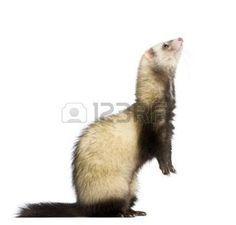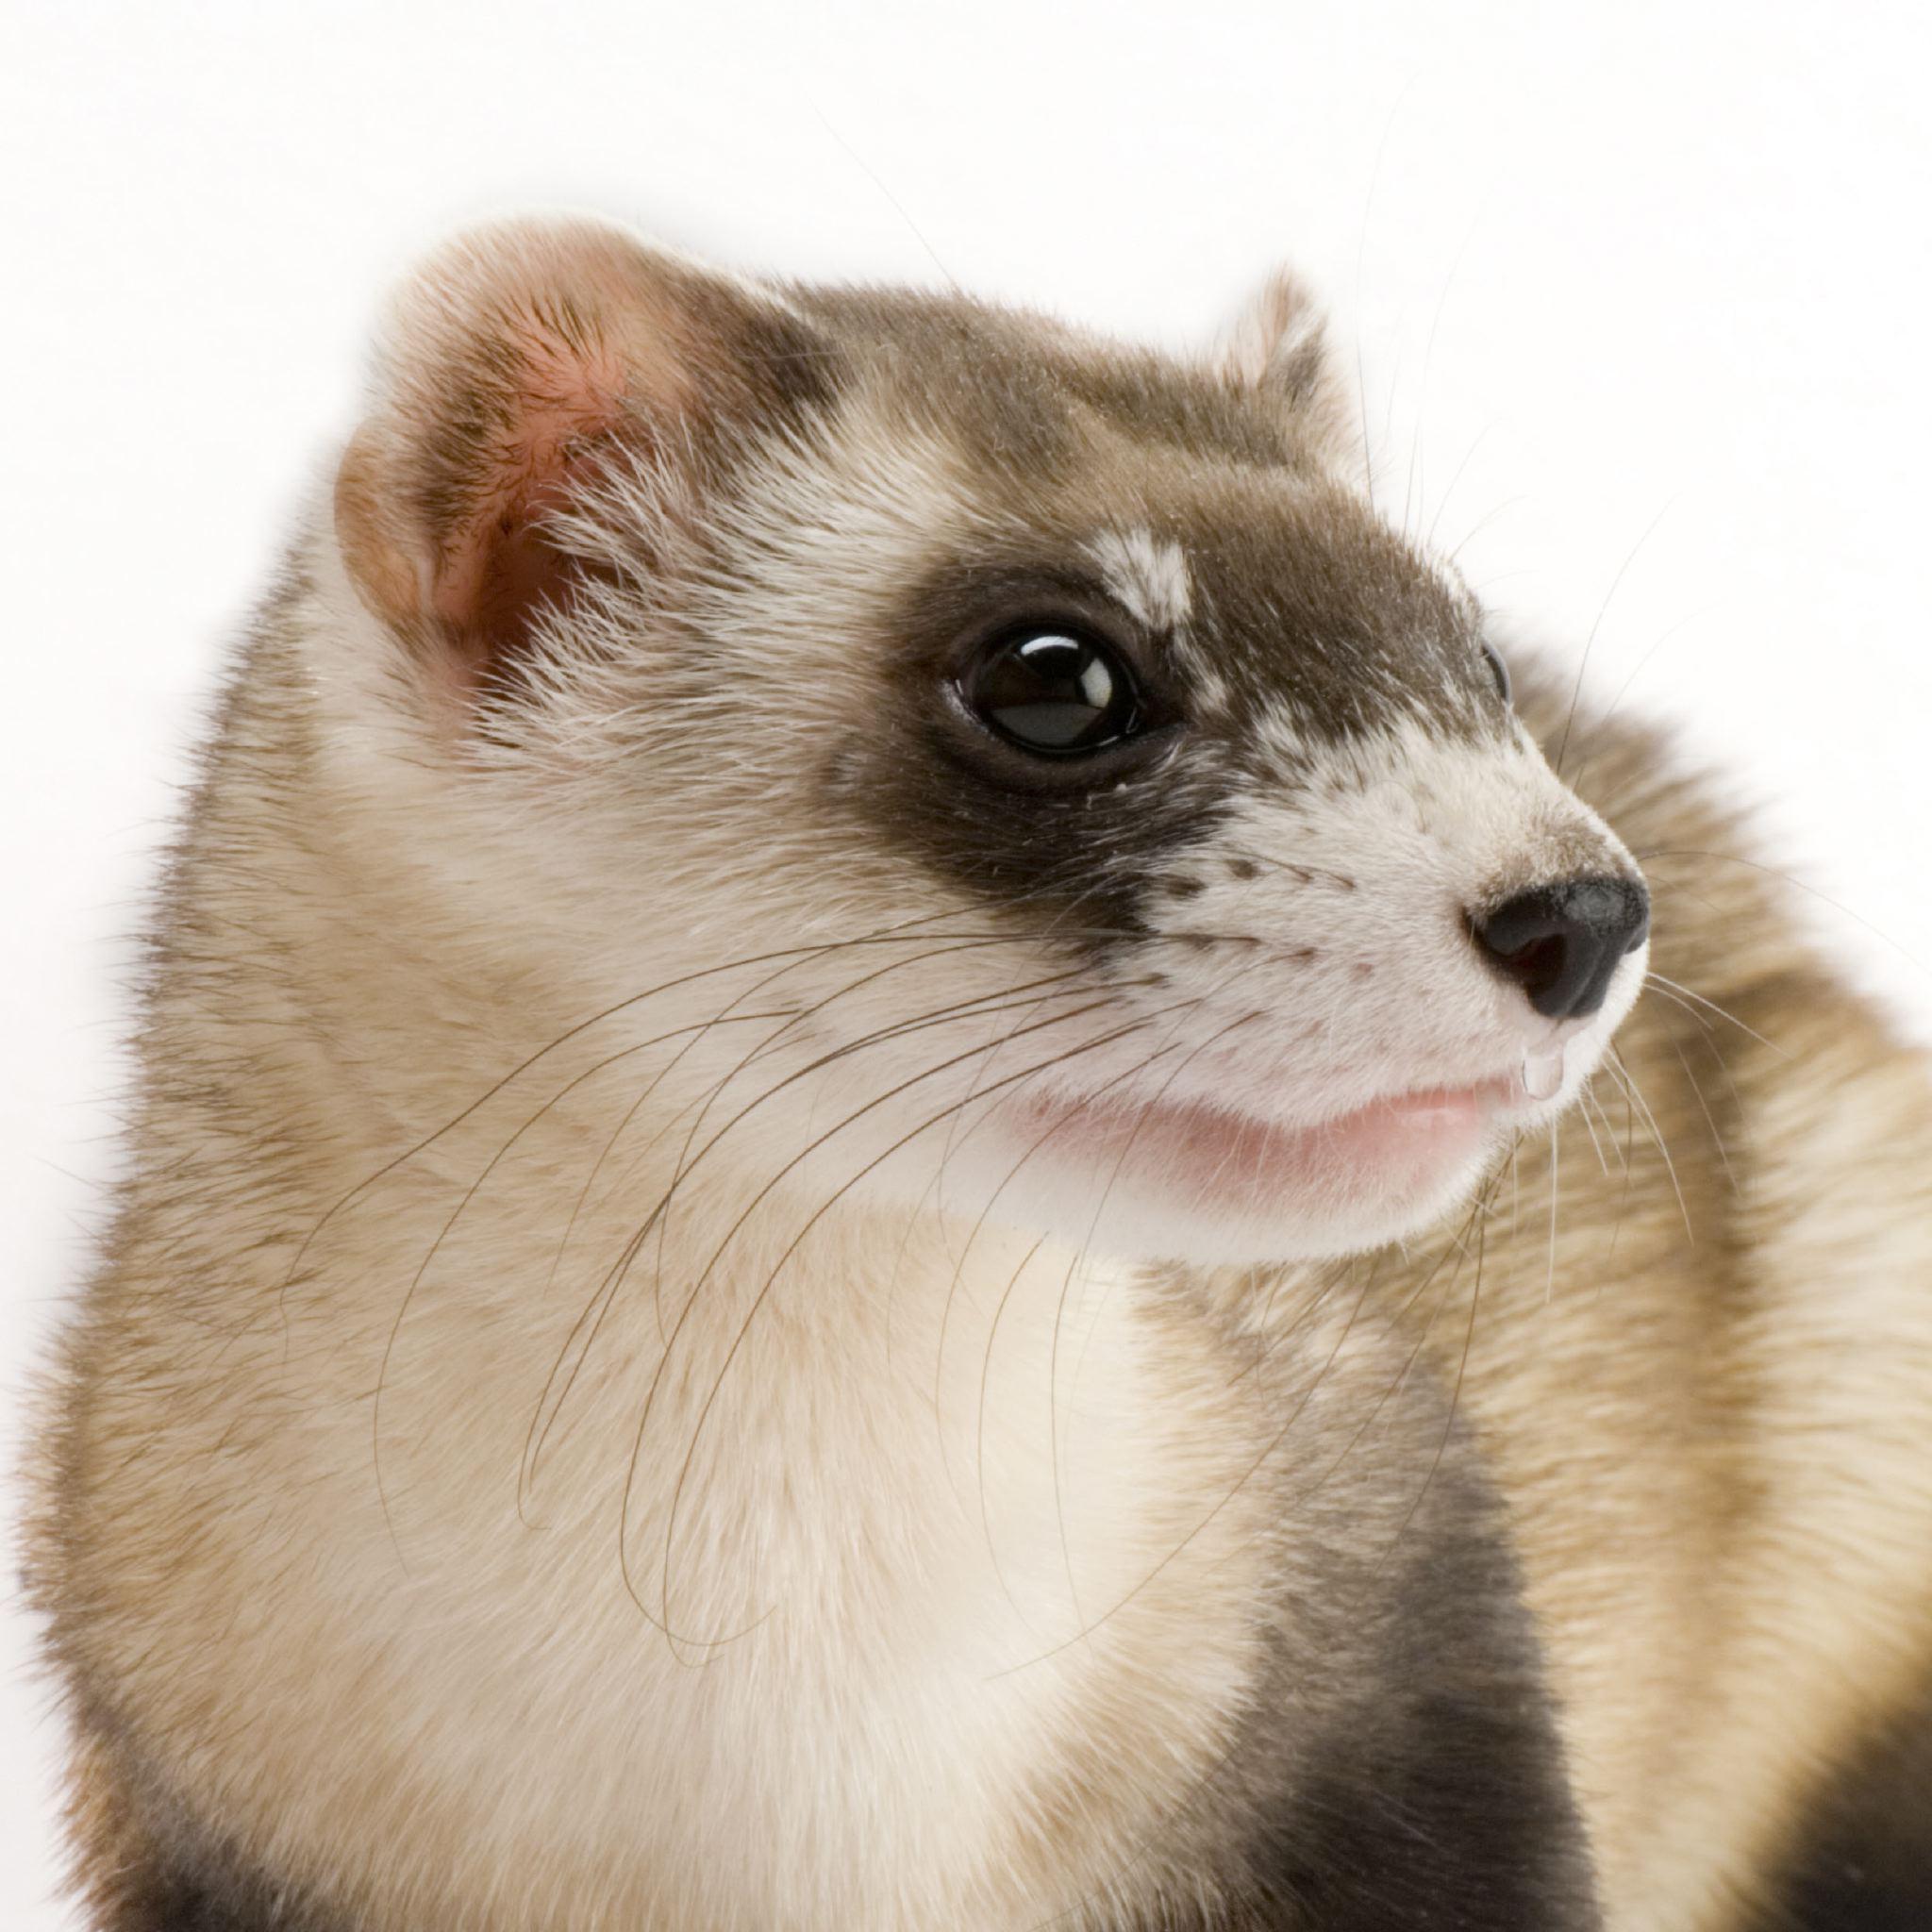The first image is the image on the left, the second image is the image on the right. Given the left and right images, does the statement "There is at least one black footed ferret looking to the right side of the image." hold true? Answer yes or no. Yes. The first image is the image on the left, the second image is the image on the right. Given the left and right images, does the statement "All of the ferrets are visible as a full body shot." hold true? Answer yes or no. No. 